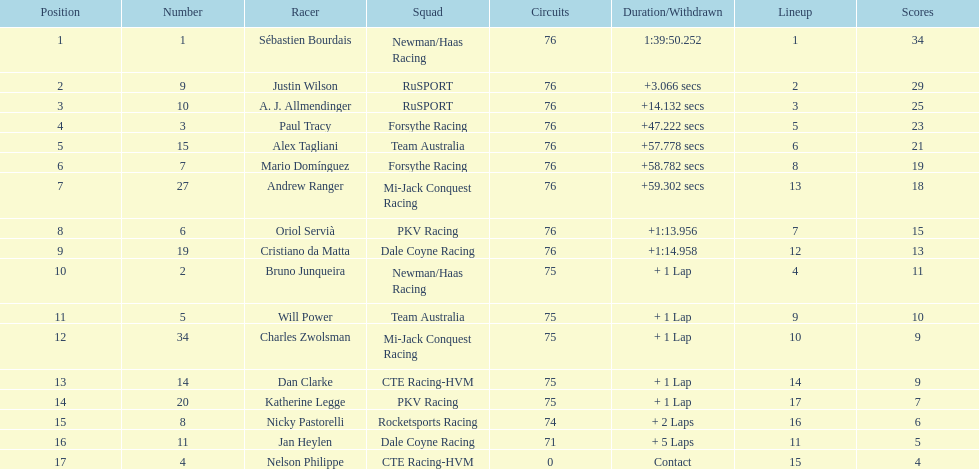How many positions are held by canada? 3. 